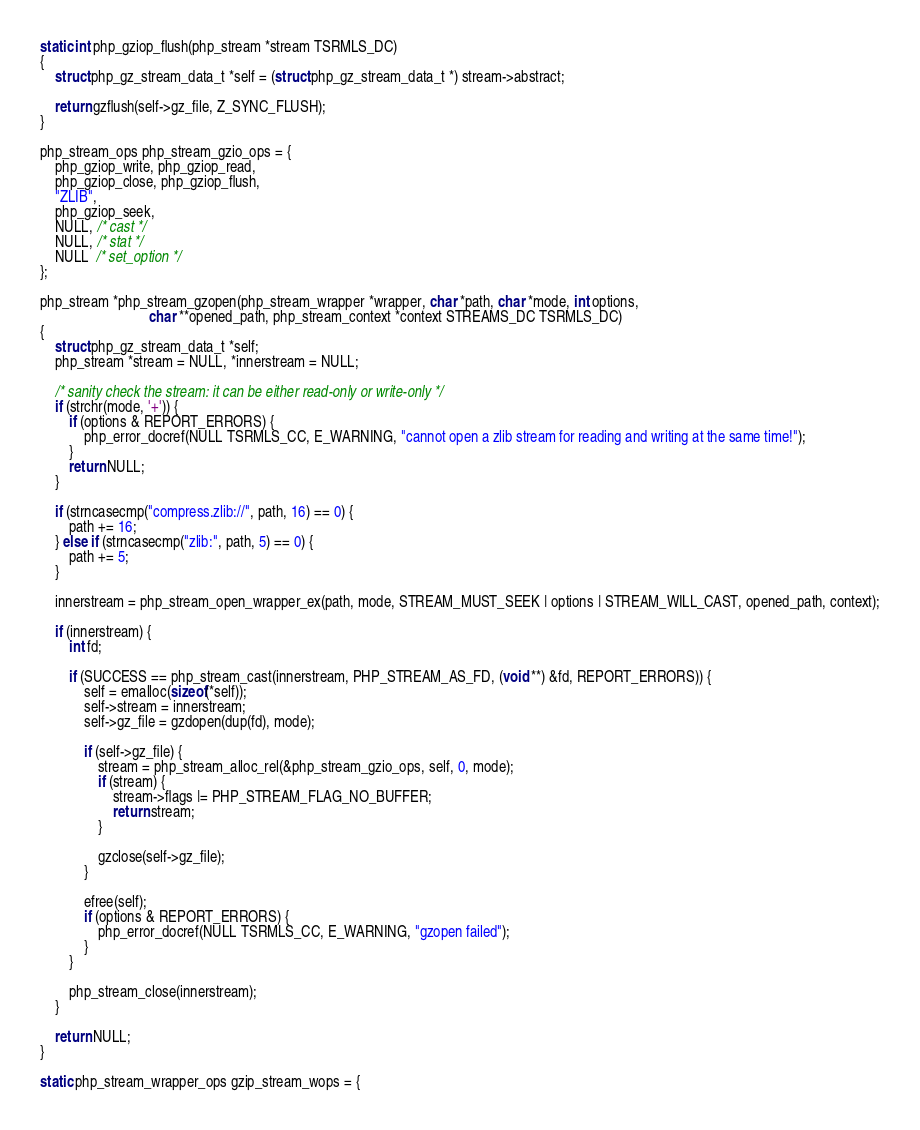<code> <loc_0><loc_0><loc_500><loc_500><_C_>
static int php_gziop_flush(php_stream *stream TSRMLS_DC)
{
	struct php_gz_stream_data_t *self = (struct php_gz_stream_data_t *) stream->abstract;

	return gzflush(self->gz_file, Z_SYNC_FLUSH);
}

php_stream_ops php_stream_gzio_ops = {
	php_gziop_write, php_gziop_read,
	php_gziop_close, php_gziop_flush,
	"ZLIB",
	php_gziop_seek, 
	NULL, /* cast */
	NULL, /* stat */
	NULL  /* set_option */
};

php_stream *php_stream_gzopen(php_stream_wrapper *wrapper, char *path, char *mode, int options, 
							  char **opened_path, php_stream_context *context STREAMS_DC TSRMLS_DC)
{
	struct php_gz_stream_data_t *self;
	php_stream *stream = NULL, *innerstream = NULL;

	/* sanity check the stream: it can be either read-only or write-only */
	if (strchr(mode, '+')) {
		if (options & REPORT_ERRORS) {
			php_error_docref(NULL TSRMLS_CC, E_WARNING, "cannot open a zlib stream for reading and writing at the same time!");
		}
		return NULL;
	}
	
	if (strncasecmp("compress.zlib://", path, 16) == 0) {
		path += 16;
	} else if (strncasecmp("zlib:", path, 5) == 0) {
		path += 5;
	}
	
	innerstream = php_stream_open_wrapper_ex(path, mode, STREAM_MUST_SEEK | options | STREAM_WILL_CAST, opened_path, context);
	
	if (innerstream) {
		int fd;

		if (SUCCESS == php_stream_cast(innerstream, PHP_STREAM_AS_FD, (void **) &fd, REPORT_ERRORS)) {
			self = emalloc(sizeof(*self));
			self->stream = innerstream;
			self->gz_file = gzdopen(dup(fd), mode);

			if (self->gz_file) {
				stream = php_stream_alloc_rel(&php_stream_gzio_ops, self, 0, mode);
				if (stream) {
					stream->flags |= PHP_STREAM_FLAG_NO_BUFFER;
					return stream;
				}

				gzclose(self->gz_file);
			}

			efree(self);
			if (options & REPORT_ERRORS) {
				php_error_docref(NULL TSRMLS_CC, E_WARNING, "gzopen failed");
			}
		}

		php_stream_close(innerstream);
	}

	return NULL;
}

static php_stream_wrapper_ops gzip_stream_wops = {</code> 